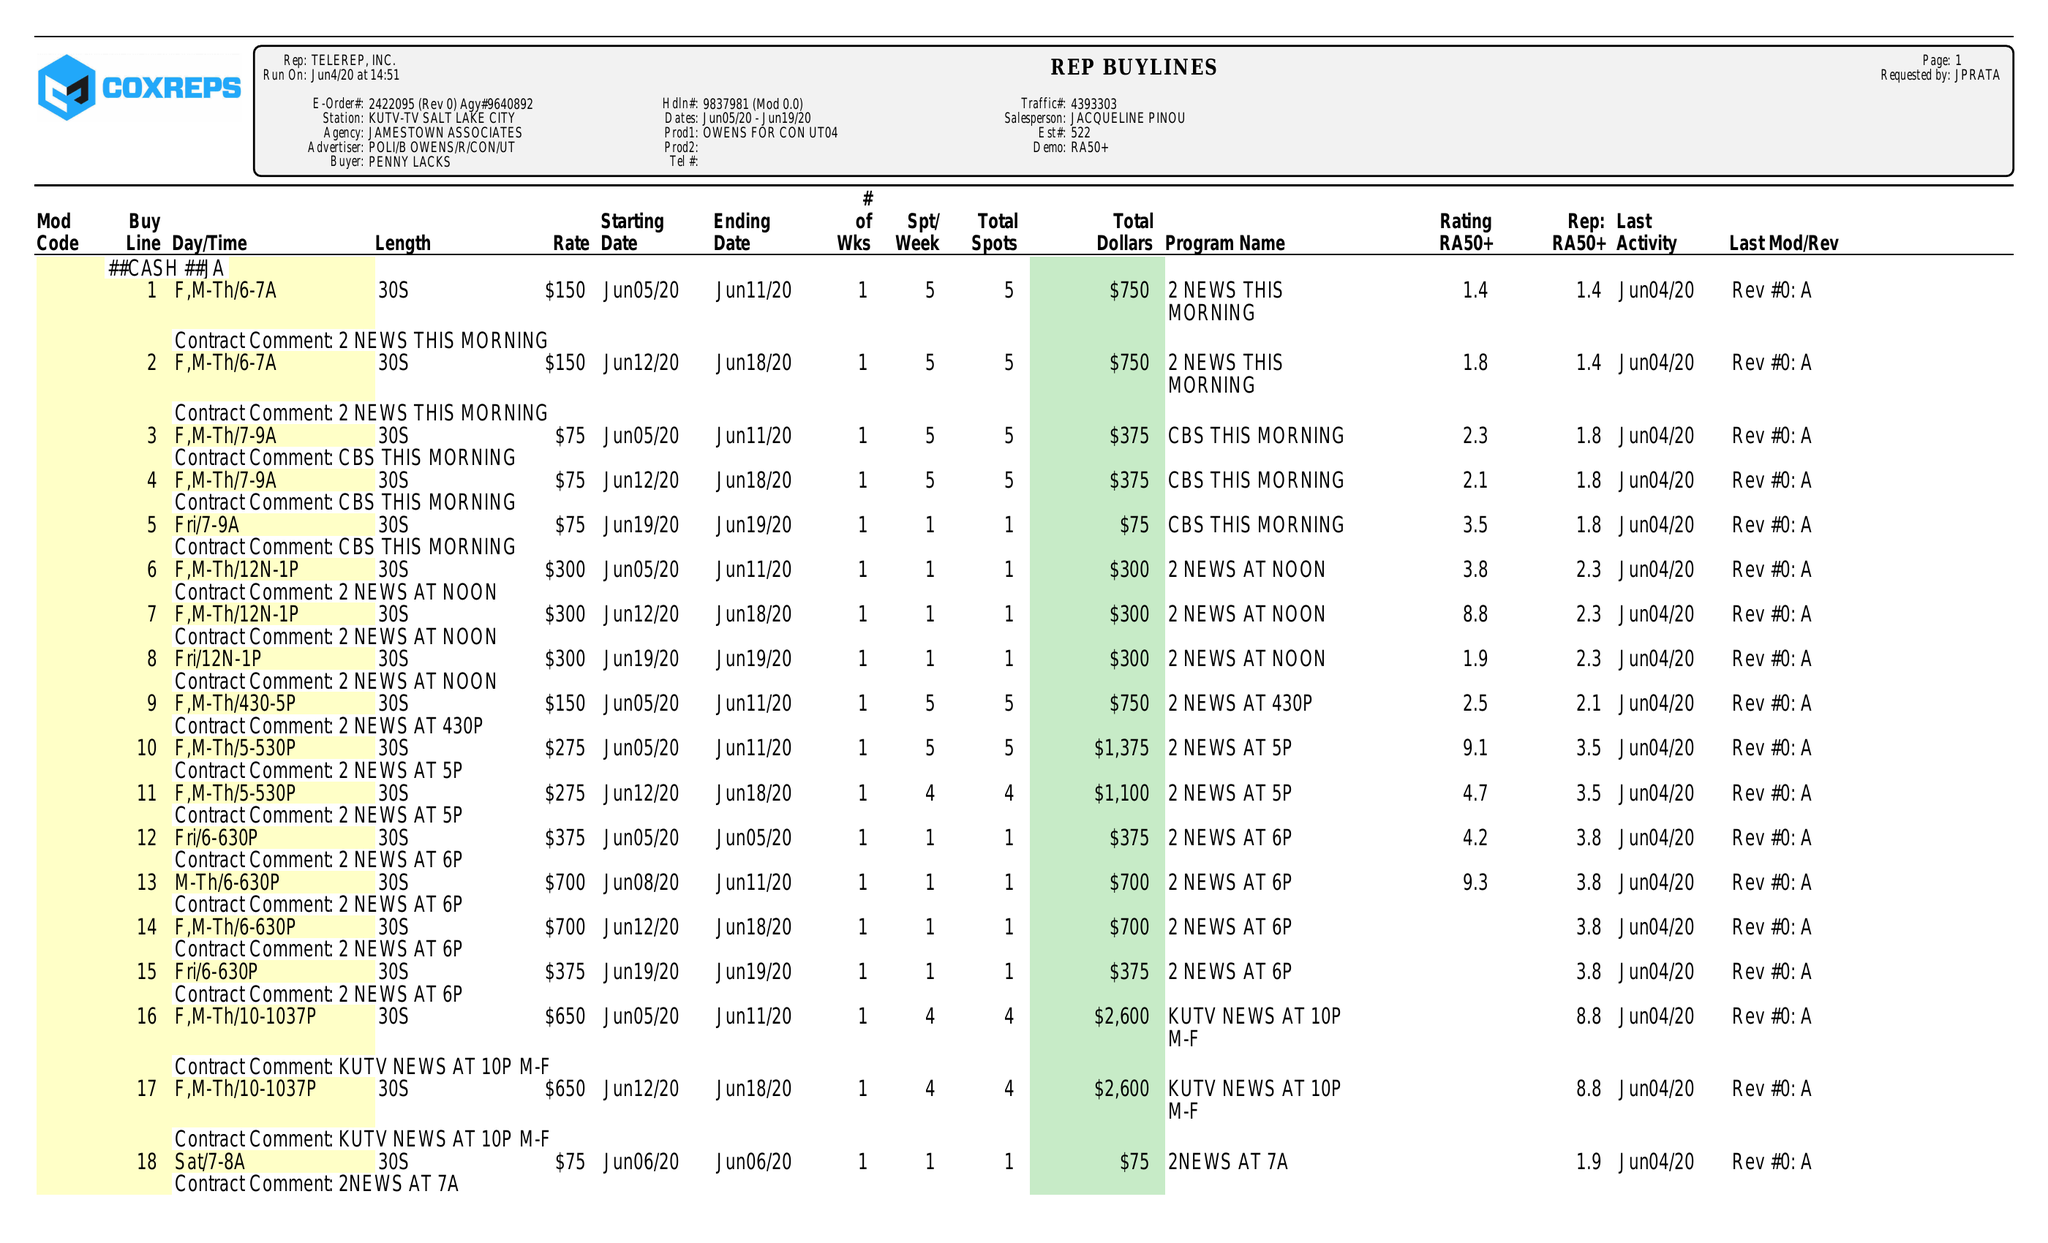What is the value for the advertiser?
Answer the question using a single word or phrase. POLI/BOWENS/R/CON/UT 